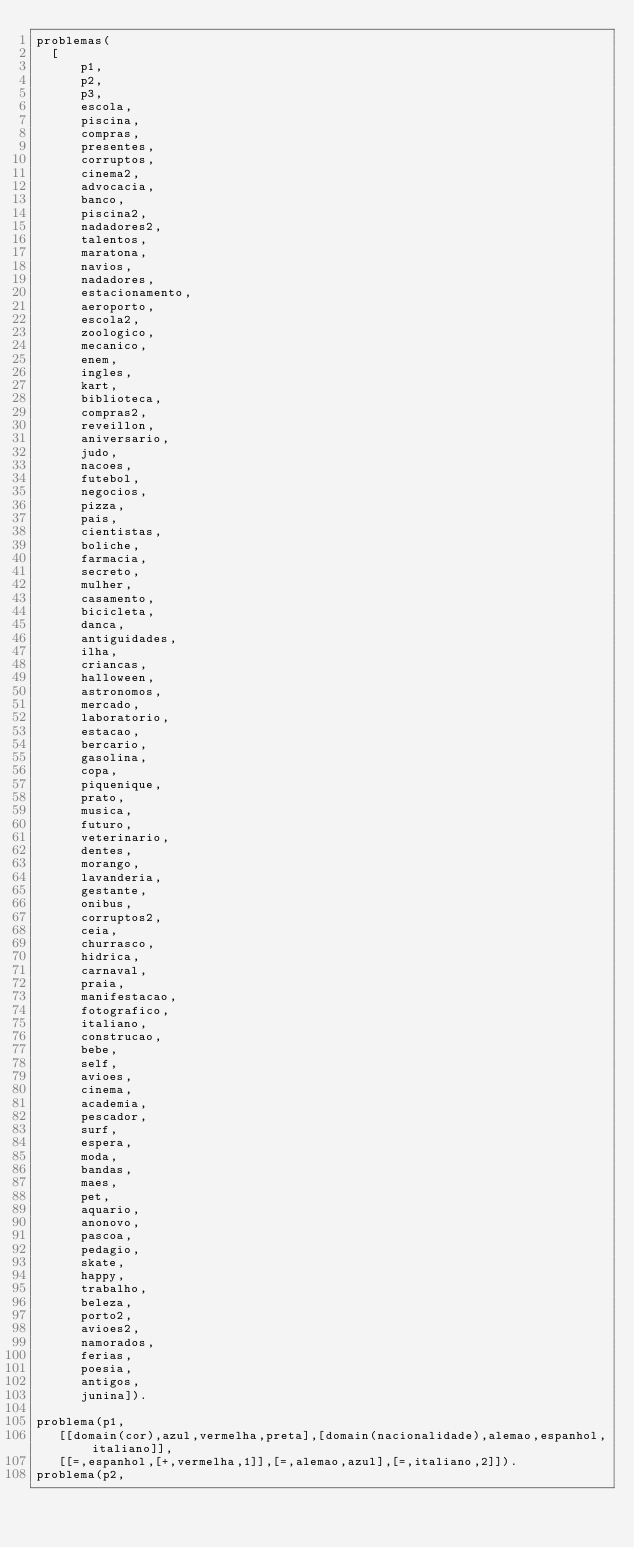<code> <loc_0><loc_0><loc_500><loc_500><_Prolog_>problemas(
	[
	    p1,
	    p2,
	    p3,
	    escola,
	    piscina,
	    compras,
	    presentes,
	    corruptos,
	    cinema2,
	    advocacia,
	    banco,
	    piscina2,
	    nadadores2,
	    talentos,
	    maratona,
	    navios,
	    nadadores,
	    estacionamento,
	    aeroporto,
	    escola2,
	    zoologico,
	    mecanico,
	    enem,
	    ingles,
	    kart,
	    biblioteca,
	    compras2,
	    reveillon,
	    aniversario,
	    judo,
	    nacoes,
	    futebol,
	    negocios,
	    pizza,
	    pais,
	    cientistas,
	    boliche,
	    farmacia,
	    secreto,
	    mulher,
	    casamento,
	    bicicleta,
	    danca,
	    antiguidades,
	    ilha,
	    criancas,
	    halloween,
	    astronomos,
	    mercado,
	    laboratorio,
	    estacao,
	    bercario,
	    gasolina,
	    copa,
	    piquenique,
	    prato,
	    musica,
	    futuro,
	    veterinario,
	    dentes,
	    morango,
	    lavanderia,
	    gestante,
	    onibus,
	    corruptos2,
	    ceia,
	    churrasco,
	    hidrica,
	    carnaval,
	    praia,
	    manifestacao,
	    fotografico,
	    italiano,
	    construcao,
	    bebe,
	    self,
	    avioes,
	    cinema,
	    academia,
	    pescador,
	    surf,
	    espera,
	    moda,
	    bandas,
	    maes,
	    pet,
	    aquario,
	    anonovo,
	    pascoa,
	    pedagio,
	    skate,
	    happy,
	    trabalho,
	    beleza,
	    porto2,
	    avioes2,
	    namorados,
	    ferias,
	    poesia,
	    antigos,
	    junina]).

problema(p1,
	 [[domain(cor),azul,vermelha,preta],[domain(nacionalidade),alemao,espanhol,italiano]],
	 [[=,espanhol,[+,vermelha,1]],[=,alemao,azul],[=,italiano,2]]).
problema(p2,</code> 